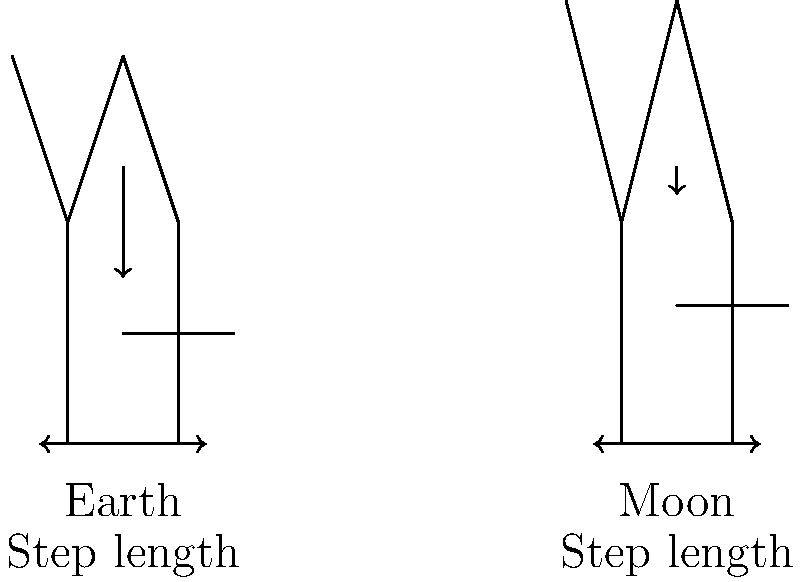Considering the biomechanical differences between walking on Earth and the Moon, which of the following statements is correct? Focus on the impact of reduced gravity on the Moon and its effects on human locomotion. To answer this question, let's analyze the biomechanical differences step-by-step:

1. Gravity:
   - Earth's gravity: approximately 9.8 m/s²
   - Moon's gravity: approximately 1.62 m/s² (about 1/6 of Earth's gravity)

2. Body weight:
   - On Earth: Full body weight
   - On Moon: Approximately 1/6 of Earth body weight

3. Ground reaction force:
   - On Earth: Equal to body weight during standing, varies during walking
   - On Moon: Reduced due to lower gravity, approximately 1/6 of Earth

4. Gait cycle:
   - On Earth: Normal walking pattern with alternating stance and swing phases
   - On Moon: Extended flight phase due to reduced gravity

5. Step length:
   - On Earth: Normal step length
   - On Moon: Increased step length due to reduced gravity and longer flight phase

6. Muscle activation:
   - On Earth: Normal muscle activation patterns for walking
   - On Moon: Reduced muscle activation needed for propulsion, but increased for stability

7. Energy expenditure:
   - On Earth: Normal energy expenditure for walking
   - On Moon: Potentially lower energy expenditure per step, but may increase due to the need for balance and control

8. Balance and stability:
   - On Earth: Normal balance mechanisms
   - On Moon: Increased challenge in maintaining balance due to reduced gravity feedback

Given these differences, the correct statement would focus on the increased step length and altered gait pattern on the Moon due to reduced gravity.
Answer: Increased step length and longer flight phase on the Moon 